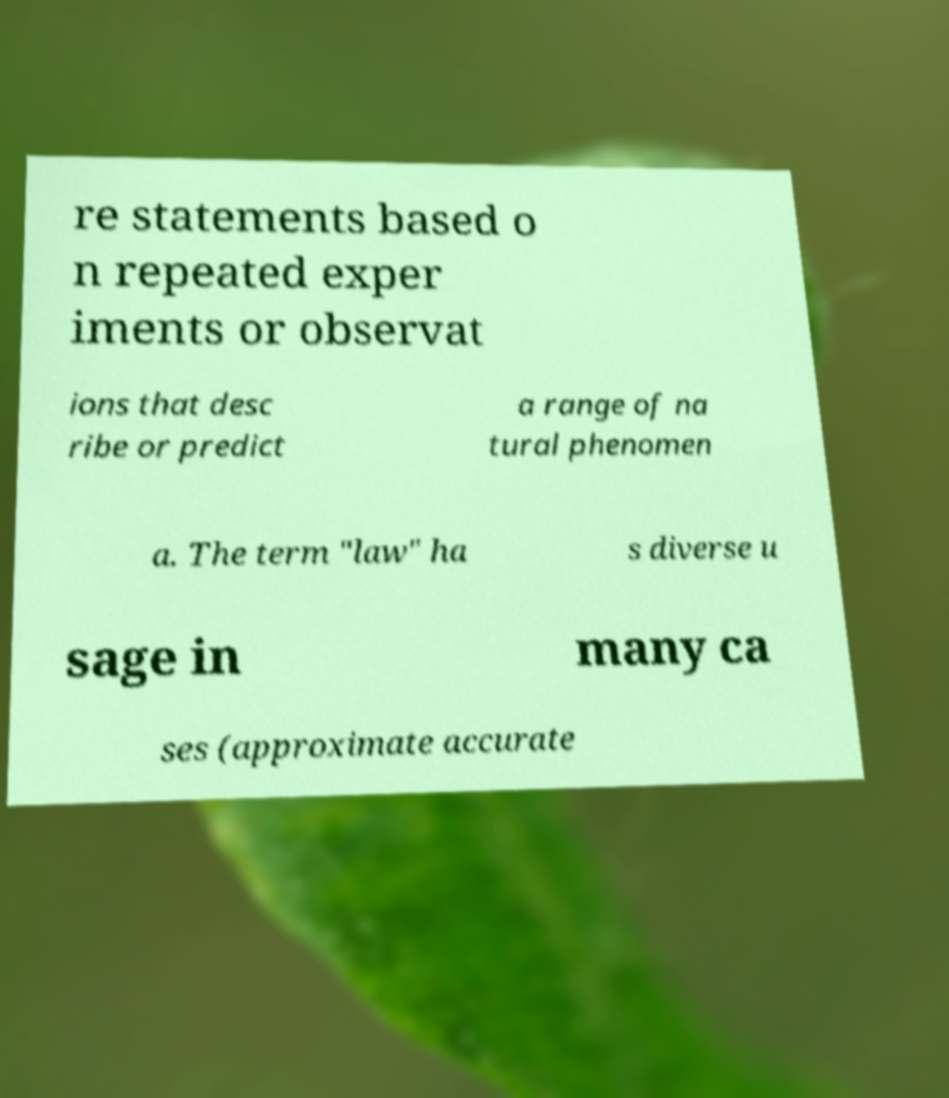There's text embedded in this image that I need extracted. Can you transcribe it verbatim? re statements based o n repeated exper iments or observat ions that desc ribe or predict a range of na tural phenomen a. The term "law" ha s diverse u sage in many ca ses (approximate accurate 